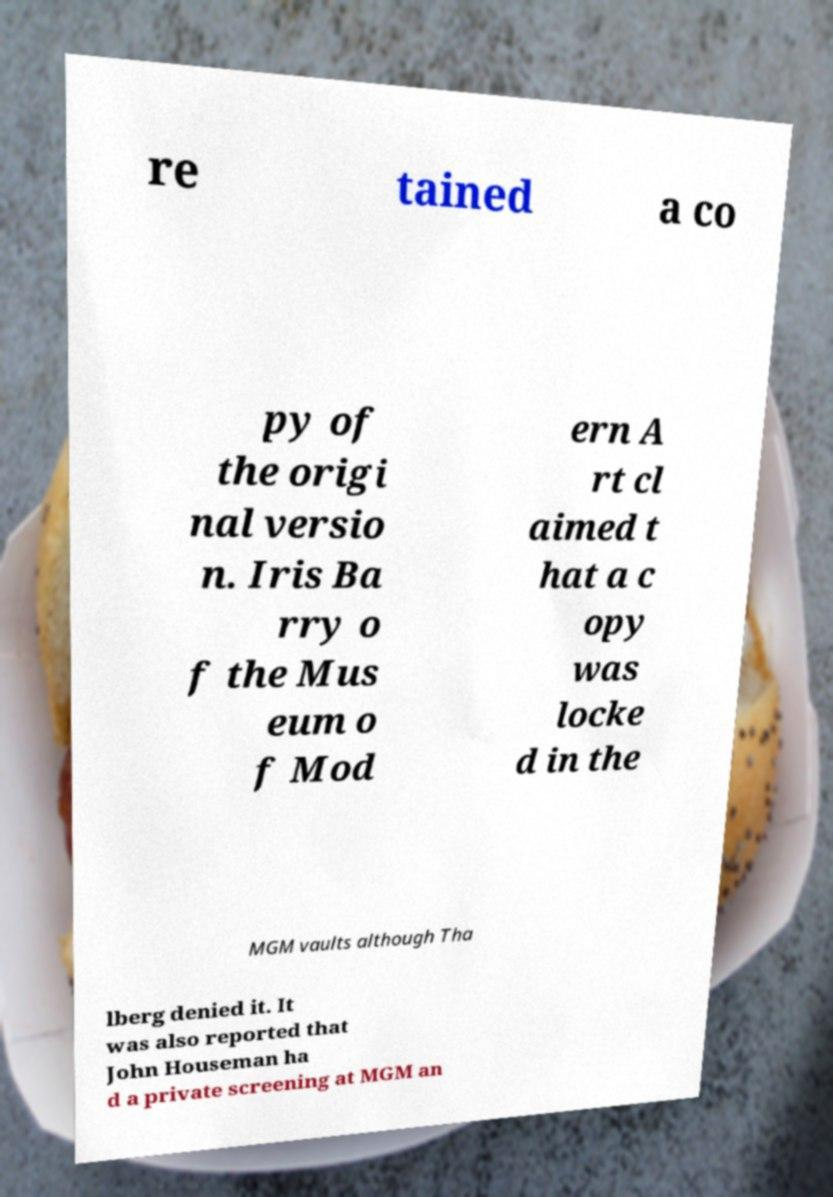Could you assist in decoding the text presented in this image and type it out clearly? re tained a co py of the origi nal versio n. Iris Ba rry o f the Mus eum o f Mod ern A rt cl aimed t hat a c opy was locke d in the MGM vaults although Tha lberg denied it. It was also reported that John Houseman ha d a private screening at MGM an 